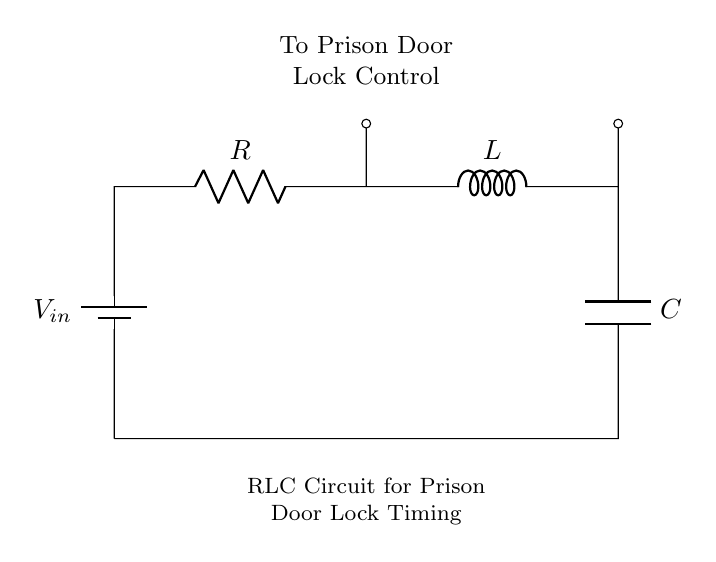What is the input voltage in this circuit? The input voltage is represented by the symbol V in the circuit diagram, typically associated with a battery or voltage source. There is no specific value given in this diagram, but it indicates that there is a voltage being applied to the circuit.
Answer: V What components are present in this RLC circuit? This circuit contains three primary components: a resistor (R), an inductor (L), and a capacitor (C). These components are essential parts of an RLC circuit, which is characterized by the combination of resistance, inductance, and capacitance in its operation.
Answer: Resistor, Inductor, Capacitor What does the RLC circuit control? The RLC circuit is connected to the prison door lock control, allowing it to manage the timing mechanism for locking and unlocking the door. This function is critical in controlling access and security in a prison environment.
Answer: Prison Door Lock Control What is the role of the inductor in this circuit? The inductor in this circuit stores energy in a magnetic field when current flows through it, which affects the timing characteristics of the circuit. This property is utilized in timing applications, such as controlling the delay in the door locking mechanism.
Answer: Store energy How does the capacitor influence the timing in the circuit? The capacitor stores energy in the form of an electric field and releases it, influencing the timing and frequency response of the RLC circuit. In this context, it is crucial for creating time delays that are needed for controlling the locking mechanism of the prison door.
Answer: Timing delay What is the output of the RLC circuit? The output of this RLC circuit is the control signal sent to engage or disengage the prison door lock mechanism, depending on the timing dictated by the reaction of R, L, and C to the input voltage.
Answer: Control signal What type of circuit is this? This is a series RLC circuit, as it consists of a resistor, inductor, and capacitor connected in series to a voltage source without branches. The configuration is integral to RLC circuits used in timing applications.
Answer: Series RLC Circuit 